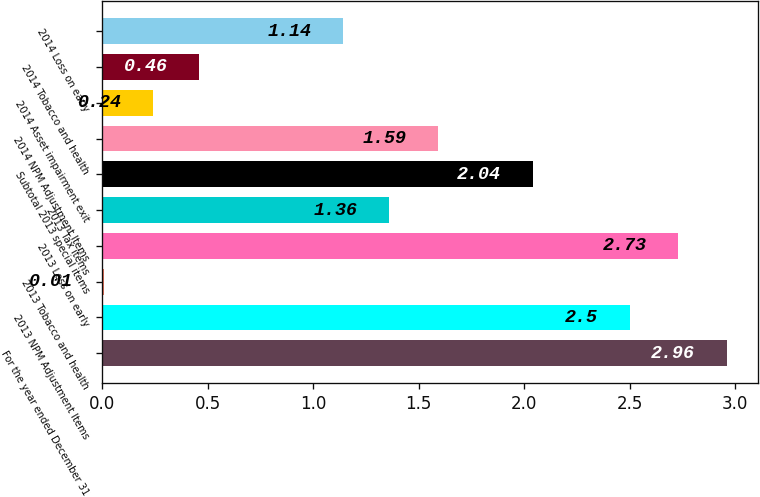Convert chart to OTSL. <chart><loc_0><loc_0><loc_500><loc_500><bar_chart><fcel>For the year ended December 31<fcel>2013 NPM Adjustment Items<fcel>2013 Tobacco and health<fcel>2013 Loss on early<fcel>2013 Tax items<fcel>Subtotal 2013 special items<fcel>2014 NPM Adjustment Items<fcel>2014 Asset impairment exit<fcel>2014 Tobacco and health<fcel>2014 Loss on early<nl><fcel>2.96<fcel>2.5<fcel>0.01<fcel>2.73<fcel>1.36<fcel>2.04<fcel>1.59<fcel>0.24<fcel>0.46<fcel>1.14<nl></chart> 